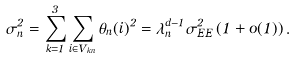<formula> <loc_0><loc_0><loc_500><loc_500>\sigma _ { n } ^ { 2 } = \sum _ { k = 1 } ^ { 3 } \sum _ { i \in V _ { k n } } \theta _ { n } ( i ) ^ { 2 } = { \lambda } _ { n } ^ { d - 1 } \sigma ^ { 2 } _ { E E } \left ( 1 + o ( 1 ) \right ) .</formula> 